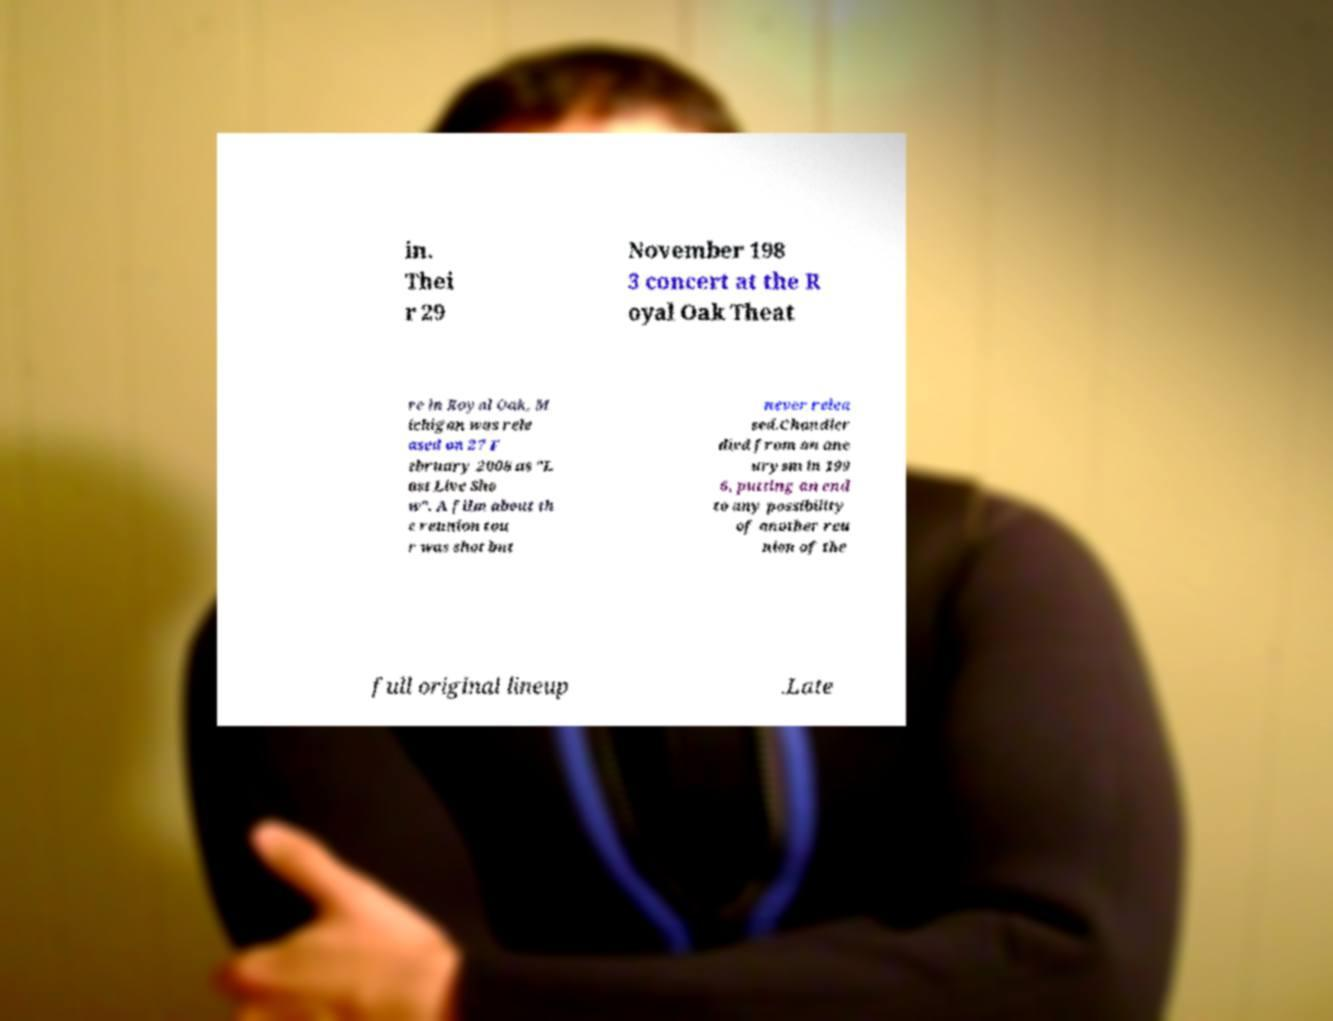Can you accurately transcribe the text from the provided image for me? in. Thei r 29 November 198 3 concert at the R oyal Oak Theat re in Royal Oak, M ichigan was rele ased on 27 F ebruary 2008 as "L ast Live Sho w". A film about th e reunion tou r was shot but never relea sed.Chandler died from an ane urysm in 199 6, putting an end to any possibility of another reu nion of the full original lineup .Late 